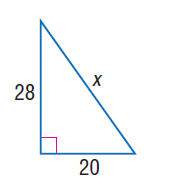Question: Find x.
Choices:
A. 8 \sqrt { 6 }
B. 20
C. 28
D. 4 \sqrt { 74 }
Answer with the letter. Answer: D 